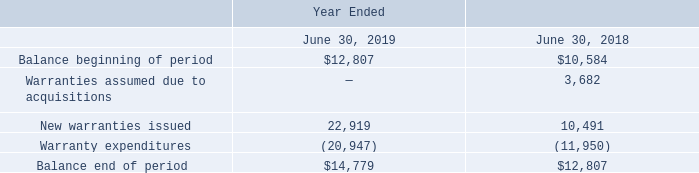Accrued Warranty
The following table summarizes the activity related to the Company’s product warranty liability during the following periods (in thousands):
Which years does the table provide information for the Company’s product warranty liability? 2019, 2018. What was the Balance beginning of period in 2018?
Answer scale should be: thousand. 10,584. What was the amount of new warranties issued in 2019?
Answer scale should be: thousand. 22,919. How many years did the Balance beginning of period exceed $10,000 thousand? 2019##2018
Answer: 2. What was the change in the Warranty expenditures between 2018 and 2019?
Answer scale should be: thousand. -20,947-(-11,950)
Answer: -8997. What was the percentage change in New warranties issued between 2018 and 2019?
Answer scale should be: percent. (22,919-10,491)/10,491
Answer: 118.46. 